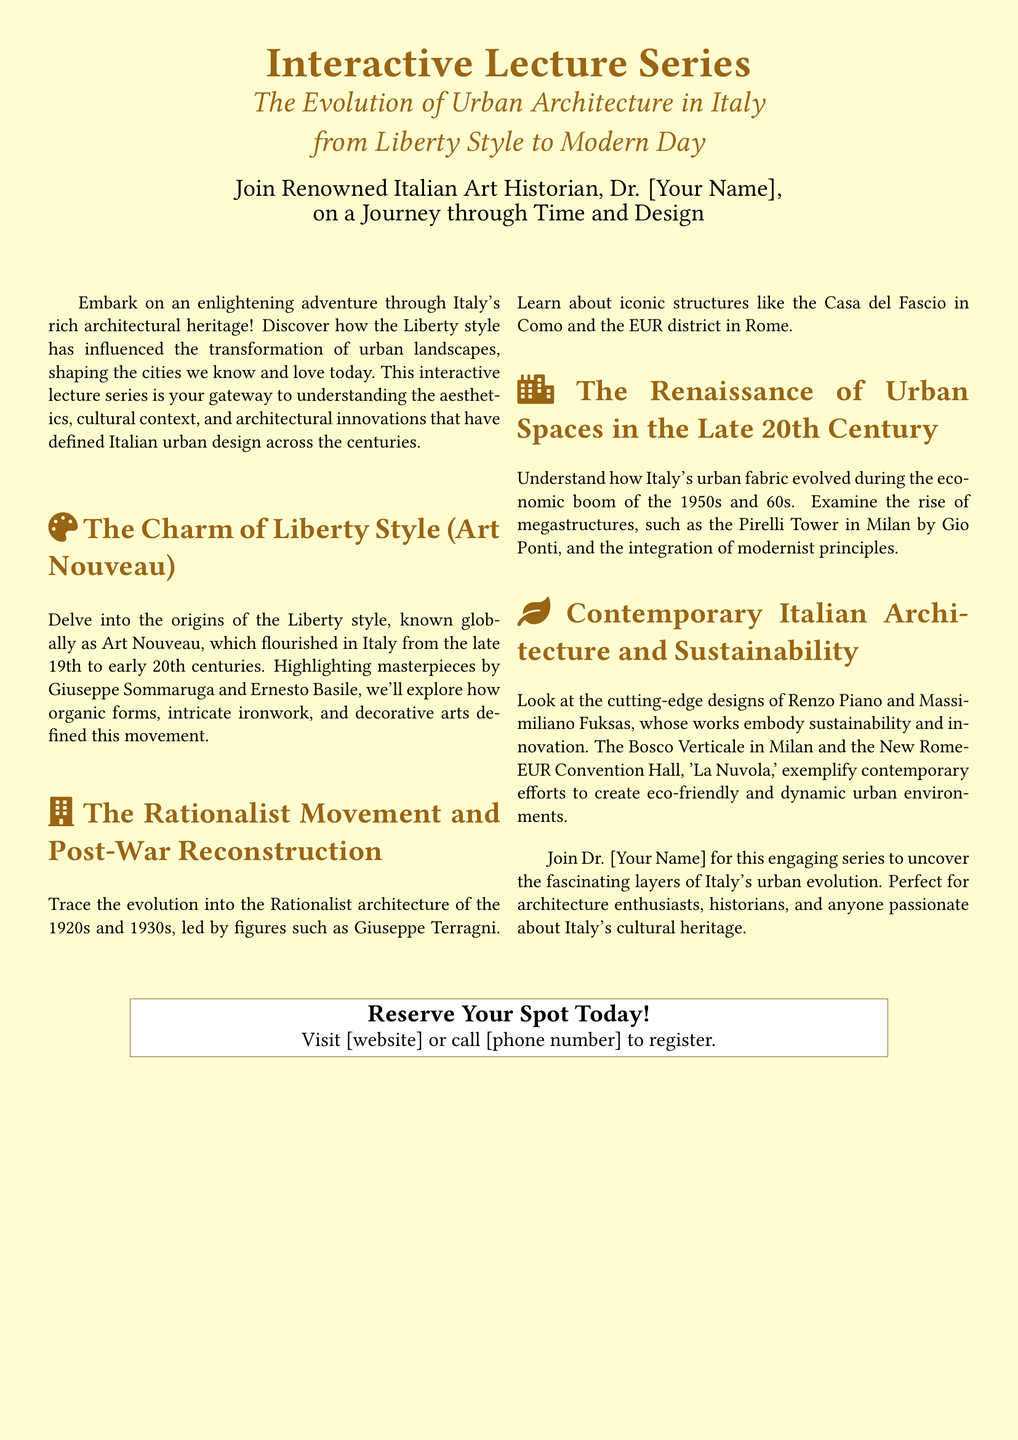What is the title of the lecture series? The title of the lecture series is specified prominently in the document.
Answer: The Evolution of Urban Architecture in Italy from Liberty Style to Modern Day Who is the speaker of the lecture series? The document mentions the speaker as an Italian art historian but does not provide a specific name.
Answer: Dr. [Your Name] Which architectural movement is primarily discussed in the first section? The first section focuses on the origins and characteristics of a specific architectural style known worldwide.
Answer: Liberty Style (Art Nouveau) What major architectural work is associated with Giuseppe Terragni? The document lists an iconic structure representative of Rationalist architecture associated with the mentioned figure.
Answer: Casa del Fascio Which modern architectural design is highlighted for sustainability? A specific contemporary architectural work is cited as a notable example of eco-friendly design.
Answer: Bosco Verticale In which decades did the Liberty style flourish in Italy? The time frame during which the Liberty style was significant in Italy is mentioned in the document.
Answer: Late 19th to early 20th centuries What does the lecture series aim to uncover? The document indicates the series has a specific goal regarding understanding Italy's architectural history.
Answer: Fascinating layers of Italy's urban evolution What can attendees do to reserve a spot? The document provides clear instructions on how to register for the lecture series.
Answer: Visit [website] or call [phone number] to register What is the ideal audience for this lecture series? The document outlines the target participants who may be interested in attending the series.
Answer: Architecture enthusiasts, historians, and anyone passionate about Italy's cultural heritage 